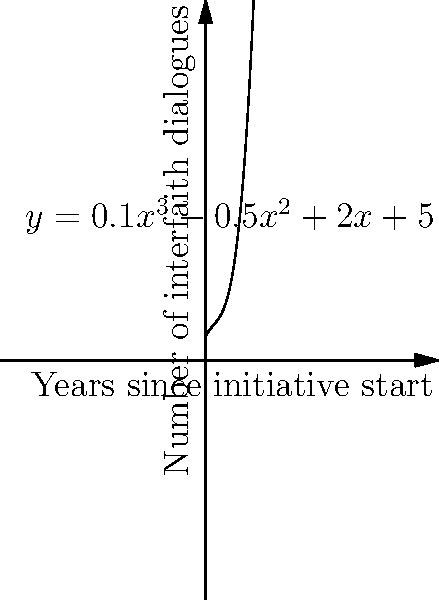The polynomial function $y = 0.1x^3 - 0.5x^2 + 2x + 5$ represents the growth of interfaith dialogue initiatives over time, where $x$ is the number of years since the initiative began and $y$ is the number of dialogues held. After how many years does the rate of growth begin to accelerate significantly? To find when the growth rate begins to accelerate significantly, we need to analyze the function's behavior:

1. The function is a cubic polynomial, which means its graph will eventually curve upward.

2. To find the point of acceleration, we need to find the function's inflection point. This occurs where the second derivative equals zero.

3. First derivative: $f'(x) = 0.3x^2 - x + 2$

4. Second derivative: $f''(x) = 0.6x - 1$

5. Set the second derivative to zero and solve:
   $0.6x - 1 = 0$
   $0.6x = 1$
   $x = \frac{1}{0.6} \approx 1.67$

6. This means the inflection point occurs approximately 1.67 years after the initiative began.

7. Rounding up to the nearest whole year, we can say that significant acceleration begins after 2 years.

This aligns with the graph, where we can see the curve begin to steepen noticeably after the 2-year mark.
Answer: 2 years 